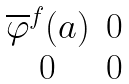Convert formula to latex. <formula><loc_0><loc_0><loc_500><loc_500>\begin{matrix} \overline { \varphi } ^ { f } ( a ) & 0 \\ 0 & 0 \end{matrix}</formula> 